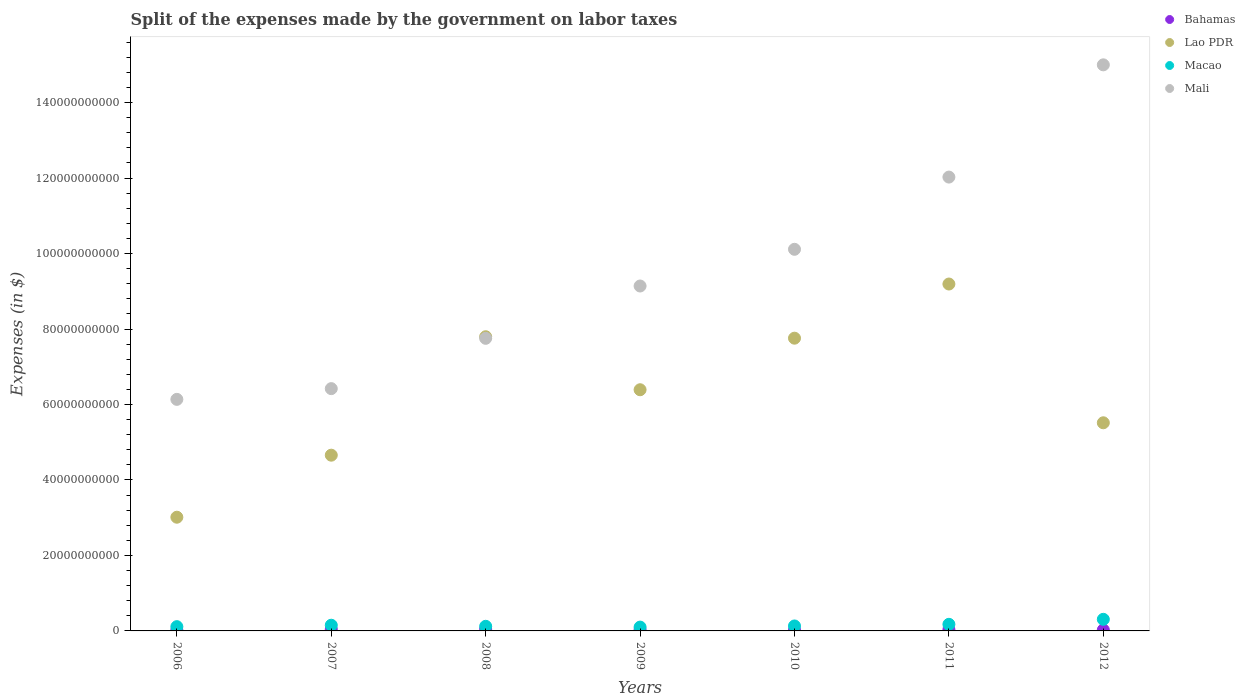How many different coloured dotlines are there?
Make the answer very short. 4. What is the expenses made by the government on labor taxes in Macao in 2008?
Your response must be concise. 1.22e+09. Across all years, what is the maximum expenses made by the government on labor taxes in Lao PDR?
Keep it short and to the point. 9.19e+1. Across all years, what is the minimum expenses made by the government on labor taxes in Lao PDR?
Give a very brief answer. 3.01e+1. What is the total expenses made by the government on labor taxes in Lao PDR in the graph?
Your answer should be very brief. 4.43e+11. What is the difference between the expenses made by the government on labor taxes in Macao in 2006 and that in 2011?
Your answer should be compact. -6.18e+08. What is the difference between the expenses made by the government on labor taxes in Lao PDR in 2006 and the expenses made by the government on labor taxes in Macao in 2007?
Your answer should be very brief. 2.86e+1. What is the average expenses made by the government on labor taxes in Mali per year?
Ensure brevity in your answer.  9.51e+1. In the year 2012, what is the difference between the expenses made by the government on labor taxes in Mali and expenses made by the government on labor taxes in Macao?
Provide a short and direct response. 1.47e+11. What is the ratio of the expenses made by the government on labor taxes in Bahamas in 2008 to that in 2011?
Your response must be concise. 1.42. Is the difference between the expenses made by the government on labor taxes in Mali in 2007 and 2008 greater than the difference between the expenses made by the government on labor taxes in Macao in 2007 and 2008?
Your response must be concise. No. What is the difference between the highest and the second highest expenses made by the government on labor taxes in Mali?
Make the answer very short. 2.97e+1. What is the difference between the highest and the lowest expenses made by the government on labor taxes in Mali?
Provide a succinct answer. 8.86e+1. Is the sum of the expenses made by the government on labor taxes in Mali in 2008 and 2010 greater than the maximum expenses made by the government on labor taxes in Macao across all years?
Offer a terse response. Yes. Is it the case that in every year, the sum of the expenses made by the government on labor taxes in Macao and expenses made by the government on labor taxes in Mali  is greater than the sum of expenses made by the government on labor taxes in Bahamas and expenses made by the government on labor taxes in Lao PDR?
Offer a very short reply. Yes. Is it the case that in every year, the sum of the expenses made by the government on labor taxes in Macao and expenses made by the government on labor taxes in Bahamas  is greater than the expenses made by the government on labor taxes in Mali?
Give a very brief answer. No. Does the expenses made by the government on labor taxes in Bahamas monotonically increase over the years?
Keep it short and to the point. No. Is the expenses made by the government on labor taxes in Macao strictly greater than the expenses made by the government on labor taxes in Mali over the years?
Offer a very short reply. No. Does the graph contain grids?
Make the answer very short. No. How many legend labels are there?
Give a very brief answer. 4. How are the legend labels stacked?
Offer a very short reply. Vertical. What is the title of the graph?
Offer a very short reply. Split of the expenses made by the government on labor taxes. Does "Myanmar" appear as one of the legend labels in the graph?
Ensure brevity in your answer.  No. What is the label or title of the X-axis?
Give a very brief answer. Years. What is the label or title of the Y-axis?
Your answer should be compact. Expenses (in $). What is the Expenses (in $) in Bahamas in 2006?
Offer a very short reply. 2.35e+08. What is the Expenses (in $) of Lao PDR in 2006?
Provide a succinct answer. 3.01e+1. What is the Expenses (in $) in Macao in 2006?
Give a very brief answer. 1.13e+09. What is the Expenses (in $) of Mali in 2006?
Make the answer very short. 6.14e+1. What is the Expenses (in $) in Bahamas in 2007?
Keep it short and to the point. 4.46e+08. What is the Expenses (in $) in Lao PDR in 2007?
Your answer should be very brief. 4.66e+1. What is the Expenses (in $) in Macao in 2007?
Provide a short and direct response. 1.51e+09. What is the Expenses (in $) of Mali in 2007?
Your answer should be compact. 6.42e+1. What is the Expenses (in $) in Bahamas in 2008?
Keep it short and to the point. 4.99e+08. What is the Expenses (in $) of Lao PDR in 2008?
Offer a very short reply. 7.80e+1. What is the Expenses (in $) of Macao in 2008?
Give a very brief answer. 1.22e+09. What is the Expenses (in $) of Mali in 2008?
Ensure brevity in your answer.  7.75e+1. What is the Expenses (in $) in Bahamas in 2009?
Your response must be concise. 2.78e+08. What is the Expenses (in $) of Lao PDR in 2009?
Your answer should be compact. 6.39e+1. What is the Expenses (in $) in Macao in 2009?
Your response must be concise. 1.01e+09. What is the Expenses (in $) in Mali in 2009?
Your answer should be compact. 9.14e+1. What is the Expenses (in $) in Bahamas in 2010?
Your answer should be very brief. 2.53e+08. What is the Expenses (in $) of Lao PDR in 2010?
Offer a very short reply. 7.76e+1. What is the Expenses (in $) in Macao in 2010?
Keep it short and to the point. 1.31e+09. What is the Expenses (in $) of Mali in 2010?
Provide a short and direct response. 1.01e+11. What is the Expenses (in $) in Bahamas in 2011?
Make the answer very short. 3.50e+08. What is the Expenses (in $) of Lao PDR in 2011?
Offer a terse response. 9.19e+1. What is the Expenses (in $) of Macao in 2011?
Offer a terse response. 1.75e+09. What is the Expenses (in $) of Mali in 2011?
Give a very brief answer. 1.20e+11. What is the Expenses (in $) of Bahamas in 2012?
Provide a short and direct response. 2.69e+08. What is the Expenses (in $) in Lao PDR in 2012?
Ensure brevity in your answer.  5.52e+1. What is the Expenses (in $) of Macao in 2012?
Give a very brief answer. 3.07e+09. What is the Expenses (in $) in Mali in 2012?
Offer a terse response. 1.50e+11. Across all years, what is the maximum Expenses (in $) in Bahamas?
Your answer should be very brief. 4.99e+08. Across all years, what is the maximum Expenses (in $) in Lao PDR?
Your response must be concise. 9.19e+1. Across all years, what is the maximum Expenses (in $) of Macao?
Provide a succinct answer. 3.07e+09. Across all years, what is the maximum Expenses (in $) in Mali?
Offer a terse response. 1.50e+11. Across all years, what is the minimum Expenses (in $) in Bahamas?
Offer a terse response. 2.35e+08. Across all years, what is the minimum Expenses (in $) in Lao PDR?
Provide a succinct answer. 3.01e+1. Across all years, what is the minimum Expenses (in $) in Macao?
Ensure brevity in your answer.  1.01e+09. Across all years, what is the minimum Expenses (in $) in Mali?
Offer a terse response. 6.14e+1. What is the total Expenses (in $) of Bahamas in the graph?
Provide a short and direct response. 2.33e+09. What is the total Expenses (in $) in Lao PDR in the graph?
Offer a very short reply. 4.43e+11. What is the total Expenses (in $) of Macao in the graph?
Keep it short and to the point. 1.10e+1. What is the total Expenses (in $) in Mali in the graph?
Ensure brevity in your answer.  6.66e+11. What is the difference between the Expenses (in $) in Bahamas in 2006 and that in 2007?
Your answer should be very brief. -2.10e+08. What is the difference between the Expenses (in $) in Lao PDR in 2006 and that in 2007?
Offer a very short reply. -1.64e+1. What is the difference between the Expenses (in $) of Macao in 2006 and that in 2007?
Provide a succinct answer. -3.76e+08. What is the difference between the Expenses (in $) of Mali in 2006 and that in 2007?
Your answer should be compact. -2.84e+09. What is the difference between the Expenses (in $) in Bahamas in 2006 and that in 2008?
Offer a very short reply. -2.64e+08. What is the difference between the Expenses (in $) of Lao PDR in 2006 and that in 2008?
Offer a terse response. -4.78e+1. What is the difference between the Expenses (in $) in Macao in 2006 and that in 2008?
Your response must be concise. -9.28e+07. What is the difference between the Expenses (in $) in Mali in 2006 and that in 2008?
Your answer should be compact. -1.62e+1. What is the difference between the Expenses (in $) in Bahamas in 2006 and that in 2009?
Provide a short and direct response. -4.27e+07. What is the difference between the Expenses (in $) in Lao PDR in 2006 and that in 2009?
Your answer should be compact. -3.38e+1. What is the difference between the Expenses (in $) of Macao in 2006 and that in 2009?
Give a very brief answer. 1.18e+08. What is the difference between the Expenses (in $) in Mali in 2006 and that in 2009?
Your answer should be compact. -3.00e+1. What is the difference between the Expenses (in $) of Bahamas in 2006 and that in 2010?
Your answer should be compact. -1.79e+07. What is the difference between the Expenses (in $) of Lao PDR in 2006 and that in 2010?
Provide a short and direct response. -4.74e+1. What is the difference between the Expenses (in $) of Macao in 2006 and that in 2010?
Offer a terse response. -1.83e+08. What is the difference between the Expenses (in $) of Mali in 2006 and that in 2010?
Your answer should be very brief. -3.98e+1. What is the difference between the Expenses (in $) of Bahamas in 2006 and that in 2011?
Your answer should be very brief. -1.15e+08. What is the difference between the Expenses (in $) of Lao PDR in 2006 and that in 2011?
Offer a terse response. -6.18e+1. What is the difference between the Expenses (in $) in Macao in 2006 and that in 2011?
Ensure brevity in your answer.  -6.18e+08. What is the difference between the Expenses (in $) of Mali in 2006 and that in 2011?
Provide a succinct answer. -5.89e+1. What is the difference between the Expenses (in $) of Bahamas in 2006 and that in 2012?
Ensure brevity in your answer.  -3.41e+07. What is the difference between the Expenses (in $) of Lao PDR in 2006 and that in 2012?
Keep it short and to the point. -2.50e+1. What is the difference between the Expenses (in $) in Macao in 2006 and that in 2012?
Offer a very short reply. -1.94e+09. What is the difference between the Expenses (in $) in Mali in 2006 and that in 2012?
Keep it short and to the point. -8.86e+1. What is the difference between the Expenses (in $) in Bahamas in 2007 and that in 2008?
Make the answer very short. -5.32e+07. What is the difference between the Expenses (in $) of Lao PDR in 2007 and that in 2008?
Your answer should be very brief. -3.14e+1. What is the difference between the Expenses (in $) in Macao in 2007 and that in 2008?
Keep it short and to the point. 2.83e+08. What is the difference between the Expenses (in $) in Mali in 2007 and that in 2008?
Your answer should be very brief. -1.33e+1. What is the difference between the Expenses (in $) in Bahamas in 2007 and that in 2009?
Ensure brevity in your answer.  1.68e+08. What is the difference between the Expenses (in $) in Lao PDR in 2007 and that in 2009?
Make the answer very short. -1.73e+1. What is the difference between the Expenses (in $) of Macao in 2007 and that in 2009?
Your response must be concise. 4.94e+08. What is the difference between the Expenses (in $) in Mali in 2007 and that in 2009?
Ensure brevity in your answer.  -2.72e+1. What is the difference between the Expenses (in $) in Bahamas in 2007 and that in 2010?
Provide a succinct answer. 1.92e+08. What is the difference between the Expenses (in $) of Lao PDR in 2007 and that in 2010?
Give a very brief answer. -3.10e+1. What is the difference between the Expenses (in $) in Macao in 2007 and that in 2010?
Provide a succinct answer. 1.93e+08. What is the difference between the Expenses (in $) of Mali in 2007 and that in 2010?
Ensure brevity in your answer.  -3.69e+1. What is the difference between the Expenses (in $) in Bahamas in 2007 and that in 2011?
Provide a succinct answer. 9.54e+07. What is the difference between the Expenses (in $) of Lao PDR in 2007 and that in 2011?
Provide a short and direct response. -4.54e+1. What is the difference between the Expenses (in $) in Macao in 2007 and that in 2011?
Your response must be concise. -2.42e+08. What is the difference between the Expenses (in $) in Mali in 2007 and that in 2011?
Provide a short and direct response. -5.61e+1. What is the difference between the Expenses (in $) in Bahamas in 2007 and that in 2012?
Your answer should be very brief. 1.76e+08. What is the difference between the Expenses (in $) in Lao PDR in 2007 and that in 2012?
Offer a very short reply. -8.58e+09. What is the difference between the Expenses (in $) in Macao in 2007 and that in 2012?
Make the answer very short. -1.57e+09. What is the difference between the Expenses (in $) of Mali in 2007 and that in 2012?
Keep it short and to the point. -8.58e+1. What is the difference between the Expenses (in $) of Bahamas in 2008 and that in 2009?
Make the answer very short. 2.21e+08. What is the difference between the Expenses (in $) in Lao PDR in 2008 and that in 2009?
Provide a short and direct response. 1.40e+1. What is the difference between the Expenses (in $) in Macao in 2008 and that in 2009?
Offer a terse response. 2.11e+08. What is the difference between the Expenses (in $) of Mali in 2008 and that in 2009?
Keep it short and to the point. -1.39e+1. What is the difference between the Expenses (in $) in Bahamas in 2008 and that in 2010?
Offer a very short reply. 2.46e+08. What is the difference between the Expenses (in $) of Lao PDR in 2008 and that in 2010?
Make the answer very short. 3.81e+08. What is the difference between the Expenses (in $) in Macao in 2008 and that in 2010?
Your answer should be very brief. -9.05e+07. What is the difference between the Expenses (in $) of Mali in 2008 and that in 2010?
Give a very brief answer. -2.36e+1. What is the difference between the Expenses (in $) of Bahamas in 2008 and that in 2011?
Ensure brevity in your answer.  1.49e+08. What is the difference between the Expenses (in $) in Lao PDR in 2008 and that in 2011?
Offer a terse response. -1.40e+1. What is the difference between the Expenses (in $) of Macao in 2008 and that in 2011?
Make the answer very short. -5.25e+08. What is the difference between the Expenses (in $) in Mali in 2008 and that in 2011?
Ensure brevity in your answer.  -4.27e+1. What is the difference between the Expenses (in $) in Bahamas in 2008 and that in 2012?
Offer a very short reply. 2.29e+08. What is the difference between the Expenses (in $) in Lao PDR in 2008 and that in 2012?
Make the answer very short. 2.28e+1. What is the difference between the Expenses (in $) of Macao in 2008 and that in 2012?
Your answer should be very brief. -1.85e+09. What is the difference between the Expenses (in $) in Mali in 2008 and that in 2012?
Ensure brevity in your answer.  -7.25e+1. What is the difference between the Expenses (in $) in Bahamas in 2009 and that in 2010?
Make the answer very short. 2.47e+07. What is the difference between the Expenses (in $) of Lao PDR in 2009 and that in 2010?
Your answer should be compact. -1.37e+1. What is the difference between the Expenses (in $) in Macao in 2009 and that in 2010?
Offer a terse response. -3.01e+08. What is the difference between the Expenses (in $) of Mali in 2009 and that in 2010?
Your response must be concise. -9.72e+09. What is the difference between the Expenses (in $) of Bahamas in 2009 and that in 2011?
Your answer should be compact. -7.22e+07. What is the difference between the Expenses (in $) of Lao PDR in 2009 and that in 2011?
Your answer should be compact. -2.80e+1. What is the difference between the Expenses (in $) in Macao in 2009 and that in 2011?
Provide a short and direct response. -7.36e+08. What is the difference between the Expenses (in $) of Mali in 2009 and that in 2011?
Ensure brevity in your answer.  -2.89e+1. What is the difference between the Expenses (in $) of Bahamas in 2009 and that in 2012?
Make the answer very short. 8.64e+06. What is the difference between the Expenses (in $) in Lao PDR in 2009 and that in 2012?
Offer a very short reply. 8.76e+09. What is the difference between the Expenses (in $) of Macao in 2009 and that in 2012?
Keep it short and to the point. -2.06e+09. What is the difference between the Expenses (in $) of Mali in 2009 and that in 2012?
Offer a terse response. -5.86e+1. What is the difference between the Expenses (in $) in Bahamas in 2010 and that in 2011?
Ensure brevity in your answer.  -9.70e+07. What is the difference between the Expenses (in $) in Lao PDR in 2010 and that in 2011?
Offer a terse response. -1.43e+1. What is the difference between the Expenses (in $) in Macao in 2010 and that in 2011?
Your answer should be compact. -4.35e+08. What is the difference between the Expenses (in $) of Mali in 2010 and that in 2011?
Ensure brevity in your answer.  -1.91e+1. What is the difference between the Expenses (in $) of Bahamas in 2010 and that in 2012?
Ensure brevity in your answer.  -1.61e+07. What is the difference between the Expenses (in $) of Lao PDR in 2010 and that in 2012?
Ensure brevity in your answer.  2.24e+1. What is the difference between the Expenses (in $) of Macao in 2010 and that in 2012?
Offer a terse response. -1.76e+09. What is the difference between the Expenses (in $) in Mali in 2010 and that in 2012?
Keep it short and to the point. -4.89e+1. What is the difference between the Expenses (in $) of Bahamas in 2011 and that in 2012?
Provide a succinct answer. 8.09e+07. What is the difference between the Expenses (in $) of Lao PDR in 2011 and that in 2012?
Keep it short and to the point. 3.68e+1. What is the difference between the Expenses (in $) in Macao in 2011 and that in 2012?
Your answer should be compact. -1.32e+09. What is the difference between the Expenses (in $) of Mali in 2011 and that in 2012?
Make the answer very short. -2.97e+1. What is the difference between the Expenses (in $) in Bahamas in 2006 and the Expenses (in $) in Lao PDR in 2007?
Your answer should be very brief. -4.63e+1. What is the difference between the Expenses (in $) of Bahamas in 2006 and the Expenses (in $) of Macao in 2007?
Offer a very short reply. -1.27e+09. What is the difference between the Expenses (in $) in Bahamas in 2006 and the Expenses (in $) in Mali in 2007?
Offer a very short reply. -6.40e+1. What is the difference between the Expenses (in $) in Lao PDR in 2006 and the Expenses (in $) in Macao in 2007?
Make the answer very short. 2.86e+1. What is the difference between the Expenses (in $) of Lao PDR in 2006 and the Expenses (in $) of Mali in 2007?
Offer a very short reply. -3.41e+1. What is the difference between the Expenses (in $) of Macao in 2006 and the Expenses (in $) of Mali in 2007?
Your response must be concise. -6.31e+1. What is the difference between the Expenses (in $) in Bahamas in 2006 and the Expenses (in $) in Lao PDR in 2008?
Offer a very short reply. -7.77e+1. What is the difference between the Expenses (in $) in Bahamas in 2006 and the Expenses (in $) in Macao in 2008?
Your answer should be compact. -9.89e+08. What is the difference between the Expenses (in $) in Bahamas in 2006 and the Expenses (in $) in Mali in 2008?
Provide a short and direct response. -7.73e+1. What is the difference between the Expenses (in $) in Lao PDR in 2006 and the Expenses (in $) in Macao in 2008?
Make the answer very short. 2.89e+1. What is the difference between the Expenses (in $) in Lao PDR in 2006 and the Expenses (in $) in Mali in 2008?
Offer a very short reply. -4.74e+1. What is the difference between the Expenses (in $) in Macao in 2006 and the Expenses (in $) in Mali in 2008?
Provide a succinct answer. -7.64e+1. What is the difference between the Expenses (in $) in Bahamas in 2006 and the Expenses (in $) in Lao PDR in 2009?
Keep it short and to the point. -6.37e+1. What is the difference between the Expenses (in $) in Bahamas in 2006 and the Expenses (in $) in Macao in 2009?
Offer a terse response. -7.78e+08. What is the difference between the Expenses (in $) in Bahamas in 2006 and the Expenses (in $) in Mali in 2009?
Make the answer very short. -9.12e+1. What is the difference between the Expenses (in $) in Lao PDR in 2006 and the Expenses (in $) in Macao in 2009?
Ensure brevity in your answer.  2.91e+1. What is the difference between the Expenses (in $) of Lao PDR in 2006 and the Expenses (in $) of Mali in 2009?
Your response must be concise. -6.13e+1. What is the difference between the Expenses (in $) in Macao in 2006 and the Expenses (in $) in Mali in 2009?
Make the answer very short. -9.03e+1. What is the difference between the Expenses (in $) of Bahamas in 2006 and the Expenses (in $) of Lao PDR in 2010?
Your answer should be very brief. -7.73e+1. What is the difference between the Expenses (in $) in Bahamas in 2006 and the Expenses (in $) in Macao in 2010?
Provide a short and direct response. -1.08e+09. What is the difference between the Expenses (in $) in Bahamas in 2006 and the Expenses (in $) in Mali in 2010?
Ensure brevity in your answer.  -1.01e+11. What is the difference between the Expenses (in $) of Lao PDR in 2006 and the Expenses (in $) of Macao in 2010?
Offer a very short reply. 2.88e+1. What is the difference between the Expenses (in $) of Lao PDR in 2006 and the Expenses (in $) of Mali in 2010?
Give a very brief answer. -7.10e+1. What is the difference between the Expenses (in $) of Macao in 2006 and the Expenses (in $) of Mali in 2010?
Keep it short and to the point. -1.00e+11. What is the difference between the Expenses (in $) of Bahamas in 2006 and the Expenses (in $) of Lao PDR in 2011?
Provide a short and direct response. -9.17e+1. What is the difference between the Expenses (in $) in Bahamas in 2006 and the Expenses (in $) in Macao in 2011?
Your answer should be very brief. -1.51e+09. What is the difference between the Expenses (in $) in Bahamas in 2006 and the Expenses (in $) in Mali in 2011?
Make the answer very short. -1.20e+11. What is the difference between the Expenses (in $) of Lao PDR in 2006 and the Expenses (in $) of Macao in 2011?
Your answer should be compact. 2.84e+1. What is the difference between the Expenses (in $) in Lao PDR in 2006 and the Expenses (in $) in Mali in 2011?
Provide a succinct answer. -9.01e+1. What is the difference between the Expenses (in $) in Macao in 2006 and the Expenses (in $) in Mali in 2011?
Ensure brevity in your answer.  -1.19e+11. What is the difference between the Expenses (in $) of Bahamas in 2006 and the Expenses (in $) of Lao PDR in 2012?
Offer a very short reply. -5.49e+1. What is the difference between the Expenses (in $) in Bahamas in 2006 and the Expenses (in $) in Macao in 2012?
Give a very brief answer. -2.84e+09. What is the difference between the Expenses (in $) in Bahamas in 2006 and the Expenses (in $) in Mali in 2012?
Provide a short and direct response. -1.50e+11. What is the difference between the Expenses (in $) of Lao PDR in 2006 and the Expenses (in $) of Macao in 2012?
Offer a very short reply. 2.71e+1. What is the difference between the Expenses (in $) in Lao PDR in 2006 and the Expenses (in $) in Mali in 2012?
Your answer should be very brief. -1.20e+11. What is the difference between the Expenses (in $) in Macao in 2006 and the Expenses (in $) in Mali in 2012?
Provide a succinct answer. -1.49e+11. What is the difference between the Expenses (in $) in Bahamas in 2007 and the Expenses (in $) in Lao PDR in 2008?
Keep it short and to the point. -7.75e+1. What is the difference between the Expenses (in $) of Bahamas in 2007 and the Expenses (in $) of Macao in 2008?
Offer a terse response. -7.78e+08. What is the difference between the Expenses (in $) of Bahamas in 2007 and the Expenses (in $) of Mali in 2008?
Give a very brief answer. -7.71e+1. What is the difference between the Expenses (in $) in Lao PDR in 2007 and the Expenses (in $) in Macao in 2008?
Your answer should be compact. 4.53e+1. What is the difference between the Expenses (in $) in Lao PDR in 2007 and the Expenses (in $) in Mali in 2008?
Give a very brief answer. -3.10e+1. What is the difference between the Expenses (in $) in Macao in 2007 and the Expenses (in $) in Mali in 2008?
Your response must be concise. -7.60e+1. What is the difference between the Expenses (in $) of Bahamas in 2007 and the Expenses (in $) of Lao PDR in 2009?
Your answer should be very brief. -6.35e+1. What is the difference between the Expenses (in $) of Bahamas in 2007 and the Expenses (in $) of Macao in 2009?
Offer a terse response. -5.68e+08. What is the difference between the Expenses (in $) in Bahamas in 2007 and the Expenses (in $) in Mali in 2009?
Your answer should be very brief. -9.09e+1. What is the difference between the Expenses (in $) of Lao PDR in 2007 and the Expenses (in $) of Macao in 2009?
Make the answer very short. 4.56e+1. What is the difference between the Expenses (in $) in Lao PDR in 2007 and the Expenses (in $) in Mali in 2009?
Your response must be concise. -4.48e+1. What is the difference between the Expenses (in $) in Macao in 2007 and the Expenses (in $) in Mali in 2009?
Ensure brevity in your answer.  -8.99e+1. What is the difference between the Expenses (in $) in Bahamas in 2007 and the Expenses (in $) in Lao PDR in 2010?
Give a very brief answer. -7.71e+1. What is the difference between the Expenses (in $) in Bahamas in 2007 and the Expenses (in $) in Macao in 2010?
Your answer should be very brief. -8.69e+08. What is the difference between the Expenses (in $) in Bahamas in 2007 and the Expenses (in $) in Mali in 2010?
Your answer should be very brief. -1.01e+11. What is the difference between the Expenses (in $) in Lao PDR in 2007 and the Expenses (in $) in Macao in 2010?
Ensure brevity in your answer.  4.53e+1. What is the difference between the Expenses (in $) in Lao PDR in 2007 and the Expenses (in $) in Mali in 2010?
Offer a very short reply. -5.46e+1. What is the difference between the Expenses (in $) in Macao in 2007 and the Expenses (in $) in Mali in 2010?
Offer a terse response. -9.96e+1. What is the difference between the Expenses (in $) of Bahamas in 2007 and the Expenses (in $) of Lao PDR in 2011?
Offer a terse response. -9.15e+1. What is the difference between the Expenses (in $) in Bahamas in 2007 and the Expenses (in $) in Macao in 2011?
Make the answer very short. -1.30e+09. What is the difference between the Expenses (in $) of Bahamas in 2007 and the Expenses (in $) of Mali in 2011?
Make the answer very short. -1.20e+11. What is the difference between the Expenses (in $) in Lao PDR in 2007 and the Expenses (in $) in Macao in 2011?
Provide a short and direct response. 4.48e+1. What is the difference between the Expenses (in $) in Lao PDR in 2007 and the Expenses (in $) in Mali in 2011?
Provide a short and direct response. -7.37e+1. What is the difference between the Expenses (in $) of Macao in 2007 and the Expenses (in $) of Mali in 2011?
Offer a very short reply. -1.19e+11. What is the difference between the Expenses (in $) of Bahamas in 2007 and the Expenses (in $) of Lao PDR in 2012?
Give a very brief answer. -5.47e+1. What is the difference between the Expenses (in $) of Bahamas in 2007 and the Expenses (in $) of Macao in 2012?
Ensure brevity in your answer.  -2.63e+09. What is the difference between the Expenses (in $) of Bahamas in 2007 and the Expenses (in $) of Mali in 2012?
Offer a terse response. -1.50e+11. What is the difference between the Expenses (in $) of Lao PDR in 2007 and the Expenses (in $) of Macao in 2012?
Provide a short and direct response. 4.35e+1. What is the difference between the Expenses (in $) of Lao PDR in 2007 and the Expenses (in $) of Mali in 2012?
Keep it short and to the point. -1.03e+11. What is the difference between the Expenses (in $) in Macao in 2007 and the Expenses (in $) in Mali in 2012?
Make the answer very short. -1.48e+11. What is the difference between the Expenses (in $) of Bahamas in 2008 and the Expenses (in $) of Lao PDR in 2009?
Provide a short and direct response. -6.34e+1. What is the difference between the Expenses (in $) of Bahamas in 2008 and the Expenses (in $) of Macao in 2009?
Ensure brevity in your answer.  -5.14e+08. What is the difference between the Expenses (in $) in Bahamas in 2008 and the Expenses (in $) in Mali in 2009?
Your response must be concise. -9.09e+1. What is the difference between the Expenses (in $) in Lao PDR in 2008 and the Expenses (in $) in Macao in 2009?
Your answer should be compact. 7.69e+1. What is the difference between the Expenses (in $) in Lao PDR in 2008 and the Expenses (in $) in Mali in 2009?
Make the answer very short. -1.34e+1. What is the difference between the Expenses (in $) of Macao in 2008 and the Expenses (in $) of Mali in 2009?
Provide a short and direct response. -9.02e+1. What is the difference between the Expenses (in $) in Bahamas in 2008 and the Expenses (in $) in Lao PDR in 2010?
Offer a very short reply. -7.71e+1. What is the difference between the Expenses (in $) in Bahamas in 2008 and the Expenses (in $) in Macao in 2010?
Keep it short and to the point. -8.16e+08. What is the difference between the Expenses (in $) of Bahamas in 2008 and the Expenses (in $) of Mali in 2010?
Your response must be concise. -1.01e+11. What is the difference between the Expenses (in $) of Lao PDR in 2008 and the Expenses (in $) of Macao in 2010?
Your response must be concise. 7.66e+1. What is the difference between the Expenses (in $) of Lao PDR in 2008 and the Expenses (in $) of Mali in 2010?
Your response must be concise. -2.32e+1. What is the difference between the Expenses (in $) in Macao in 2008 and the Expenses (in $) in Mali in 2010?
Your answer should be very brief. -9.99e+1. What is the difference between the Expenses (in $) of Bahamas in 2008 and the Expenses (in $) of Lao PDR in 2011?
Keep it short and to the point. -9.14e+1. What is the difference between the Expenses (in $) in Bahamas in 2008 and the Expenses (in $) in Macao in 2011?
Provide a short and direct response. -1.25e+09. What is the difference between the Expenses (in $) of Bahamas in 2008 and the Expenses (in $) of Mali in 2011?
Your answer should be very brief. -1.20e+11. What is the difference between the Expenses (in $) in Lao PDR in 2008 and the Expenses (in $) in Macao in 2011?
Provide a succinct answer. 7.62e+1. What is the difference between the Expenses (in $) of Lao PDR in 2008 and the Expenses (in $) of Mali in 2011?
Make the answer very short. -4.23e+1. What is the difference between the Expenses (in $) in Macao in 2008 and the Expenses (in $) in Mali in 2011?
Keep it short and to the point. -1.19e+11. What is the difference between the Expenses (in $) in Bahamas in 2008 and the Expenses (in $) in Lao PDR in 2012?
Provide a succinct answer. -5.47e+1. What is the difference between the Expenses (in $) of Bahamas in 2008 and the Expenses (in $) of Macao in 2012?
Give a very brief answer. -2.57e+09. What is the difference between the Expenses (in $) in Bahamas in 2008 and the Expenses (in $) in Mali in 2012?
Your answer should be very brief. -1.50e+11. What is the difference between the Expenses (in $) in Lao PDR in 2008 and the Expenses (in $) in Macao in 2012?
Give a very brief answer. 7.49e+1. What is the difference between the Expenses (in $) of Lao PDR in 2008 and the Expenses (in $) of Mali in 2012?
Offer a terse response. -7.20e+1. What is the difference between the Expenses (in $) of Macao in 2008 and the Expenses (in $) of Mali in 2012?
Keep it short and to the point. -1.49e+11. What is the difference between the Expenses (in $) of Bahamas in 2009 and the Expenses (in $) of Lao PDR in 2010?
Offer a very short reply. -7.73e+1. What is the difference between the Expenses (in $) of Bahamas in 2009 and the Expenses (in $) of Macao in 2010?
Give a very brief answer. -1.04e+09. What is the difference between the Expenses (in $) in Bahamas in 2009 and the Expenses (in $) in Mali in 2010?
Keep it short and to the point. -1.01e+11. What is the difference between the Expenses (in $) of Lao PDR in 2009 and the Expenses (in $) of Macao in 2010?
Your response must be concise. 6.26e+1. What is the difference between the Expenses (in $) of Lao PDR in 2009 and the Expenses (in $) of Mali in 2010?
Ensure brevity in your answer.  -3.72e+1. What is the difference between the Expenses (in $) in Macao in 2009 and the Expenses (in $) in Mali in 2010?
Offer a terse response. -1.00e+11. What is the difference between the Expenses (in $) of Bahamas in 2009 and the Expenses (in $) of Lao PDR in 2011?
Your answer should be compact. -9.16e+1. What is the difference between the Expenses (in $) of Bahamas in 2009 and the Expenses (in $) of Macao in 2011?
Offer a very short reply. -1.47e+09. What is the difference between the Expenses (in $) of Bahamas in 2009 and the Expenses (in $) of Mali in 2011?
Keep it short and to the point. -1.20e+11. What is the difference between the Expenses (in $) of Lao PDR in 2009 and the Expenses (in $) of Macao in 2011?
Your answer should be very brief. 6.22e+1. What is the difference between the Expenses (in $) in Lao PDR in 2009 and the Expenses (in $) in Mali in 2011?
Your response must be concise. -5.63e+1. What is the difference between the Expenses (in $) in Macao in 2009 and the Expenses (in $) in Mali in 2011?
Keep it short and to the point. -1.19e+11. What is the difference between the Expenses (in $) of Bahamas in 2009 and the Expenses (in $) of Lao PDR in 2012?
Offer a terse response. -5.49e+1. What is the difference between the Expenses (in $) of Bahamas in 2009 and the Expenses (in $) of Macao in 2012?
Give a very brief answer. -2.79e+09. What is the difference between the Expenses (in $) in Bahamas in 2009 and the Expenses (in $) in Mali in 2012?
Make the answer very short. -1.50e+11. What is the difference between the Expenses (in $) of Lao PDR in 2009 and the Expenses (in $) of Macao in 2012?
Provide a short and direct response. 6.08e+1. What is the difference between the Expenses (in $) in Lao PDR in 2009 and the Expenses (in $) in Mali in 2012?
Make the answer very short. -8.61e+1. What is the difference between the Expenses (in $) in Macao in 2009 and the Expenses (in $) in Mali in 2012?
Your answer should be very brief. -1.49e+11. What is the difference between the Expenses (in $) of Bahamas in 2010 and the Expenses (in $) of Lao PDR in 2011?
Ensure brevity in your answer.  -9.17e+1. What is the difference between the Expenses (in $) of Bahamas in 2010 and the Expenses (in $) of Macao in 2011?
Your answer should be very brief. -1.50e+09. What is the difference between the Expenses (in $) of Bahamas in 2010 and the Expenses (in $) of Mali in 2011?
Your response must be concise. -1.20e+11. What is the difference between the Expenses (in $) in Lao PDR in 2010 and the Expenses (in $) in Macao in 2011?
Make the answer very short. 7.58e+1. What is the difference between the Expenses (in $) of Lao PDR in 2010 and the Expenses (in $) of Mali in 2011?
Your response must be concise. -4.27e+1. What is the difference between the Expenses (in $) of Macao in 2010 and the Expenses (in $) of Mali in 2011?
Give a very brief answer. -1.19e+11. What is the difference between the Expenses (in $) in Bahamas in 2010 and the Expenses (in $) in Lao PDR in 2012?
Make the answer very short. -5.49e+1. What is the difference between the Expenses (in $) in Bahamas in 2010 and the Expenses (in $) in Macao in 2012?
Offer a terse response. -2.82e+09. What is the difference between the Expenses (in $) of Bahamas in 2010 and the Expenses (in $) of Mali in 2012?
Provide a succinct answer. -1.50e+11. What is the difference between the Expenses (in $) of Lao PDR in 2010 and the Expenses (in $) of Macao in 2012?
Make the answer very short. 7.45e+1. What is the difference between the Expenses (in $) of Lao PDR in 2010 and the Expenses (in $) of Mali in 2012?
Your response must be concise. -7.24e+1. What is the difference between the Expenses (in $) in Macao in 2010 and the Expenses (in $) in Mali in 2012?
Your response must be concise. -1.49e+11. What is the difference between the Expenses (in $) of Bahamas in 2011 and the Expenses (in $) of Lao PDR in 2012?
Your response must be concise. -5.48e+1. What is the difference between the Expenses (in $) in Bahamas in 2011 and the Expenses (in $) in Macao in 2012?
Offer a terse response. -2.72e+09. What is the difference between the Expenses (in $) of Bahamas in 2011 and the Expenses (in $) of Mali in 2012?
Provide a short and direct response. -1.50e+11. What is the difference between the Expenses (in $) in Lao PDR in 2011 and the Expenses (in $) in Macao in 2012?
Provide a succinct answer. 8.88e+1. What is the difference between the Expenses (in $) of Lao PDR in 2011 and the Expenses (in $) of Mali in 2012?
Keep it short and to the point. -5.81e+1. What is the difference between the Expenses (in $) in Macao in 2011 and the Expenses (in $) in Mali in 2012?
Provide a succinct answer. -1.48e+11. What is the average Expenses (in $) of Bahamas per year?
Offer a very short reply. 3.33e+08. What is the average Expenses (in $) in Lao PDR per year?
Your response must be concise. 6.33e+1. What is the average Expenses (in $) of Macao per year?
Provide a short and direct response. 1.57e+09. What is the average Expenses (in $) in Mali per year?
Give a very brief answer. 9.51e+1. In the year 2006, what is the difference between the Expenses (in $) of Bahamas and Expenses (in $) of Lao PDR?
Give a very brief answer. -2.99e+1. In the year 2006, what is the difference between the Expenses (in $) of Bahamas and Expenses (in $) of Macao?
Provide a short and direct response. -8.96e+08. In the year 2006, what is the difference between the Expenses (in $) of Bahamas and Expenses (in $) of Mali?
Your answer should be compact. -6.11e+1. In the year 2006, what is the difference between the Expenses (in $) of Lao PDR and Expenses (in $) of Macao?
Your answer should be very brief. 2.90e+1. In the year 2006, what is the difference between the Expenses (in $) of Lao PDR and Expenses (in $) of Mali?
Give a very brief answer. -3.12e+1. In the year 2006, what is the difference between the Expenses (in $) in Macao and Expenses (in $) in Mali?
Keep it short and to the point. -6.02e+1. In the year 2007, what is the difference between the Expenses (in $) in Bahamas and Expenses (in $) in Lao PDR?
Offer a terse response. -4.61e+1. In the year 2007, what is the difference between the Expenses (in $) of Bahamas and Expenses (in $) of Macao?
Ensure brevity in your answer.  -1.06e+09. In the year 2007, what is the difference between the Expenses (in $) in Bahamas and Expenses (in $) in Mali?
Offer a very short reply. -6.38e+1. In the year 2007, what is the difference between the Expenses (in $) of Lao PDR and Expenses (in $) of Macao?
Offer a terse response. 4.51e+1. In the year 2007, what is the difference between the Expenses (in $) in Lao PDR and Expenses (in $) in Mali?
Make the answer very short. -1.76e+1. In the year 2007, what is the difference between the Expenses (in $) of Macao and Expenses (in $) of Mali?
Your answer should be compact. -6.27e+1. In the year 2008, what is the difference between the Expenses (in $) in Bahamas and Expenses (in $) in Lao PDR?
Provide a short and direct response. -7.75e+1. In the year 2008, what is the difference between the Expenses (in $) in Bahamas and Expenses (in $) in Macao?
Make the answer very short. -7.25e+08. In the year 2008, what is the difference between the Expenses (in $) in Bahamas and Expenses (in $) in Mali?
Provide a succinct answer. -7.70e+1. In the year 2008, what is the difference between the Expenses (in $) in Lao PDR and Expenses (in $) in Macao?
Give a very brief answer. 7.67e+1. In the year 2008, what is the difference between the Expenses (in $) of Lao PDR and Expenses (in $) of Mali?
Ensure brevity in your answer.  4.21e+08. In the year 2008, what is the difference between the Expenses (in $) in Macao and Expenses (in $) in Mali?
Give a very brief answer. -7.63e+1. In the year 2009, what is the difference between the Expenses (in $) of Bahamas and Expenses (in $) of Lao PDR?
Give a very brief answer. -6.36e+1. In the year 2009, what is the difference between the Expenses (in $) of Bahamas and Expenses (in $) of Macao?
Offer a terse response. -7.35e+08. In the year 2009, what is the difference between the Expenses (in $) of Bahamas and Expenses (in $) of Mali?
Your response must be concise. -9.11e+1. In the year 2009, what is the difference between the Expenses (in $) of Lao PDR and Expenses (in $) of Macao?
Give a very brief answer. 6.29e+1. In the year 2009, what is the difference between the Expenses (in $) of Lao PDR and Expenses (in $) of Mali?
Provide a succinct answer. -2.75e+1. In the year 2009, what is the difference between the Expenses (in $) in Macao and Expenses (in $) in Mali?
Offer a terse response. -9.04e+1. In the year 2010, what is the difference between the Expenses (in $) of Bahamas and Expenses (in $) of Lao PDR?
Your answer should be very brief. -7.73e+1. In the year 2010, what is the difference between the Expenses (in $) in Bahamas and Expenses (in $) in Macao?
Provide a short and direct response. -1.06e+09. In the year 2010, what is the difference between the Expenses (in $) in Bahamas and Expenses (in $) in Mali?
Make the answer very short. -1.01e+11. In the year 2010, what is the difference between the Expenses (in $) in Lao PDR and Expenses (in $) in Macao?
Your answer should be compact. 7.63e+1. In the year 2010, what is the difference between the Expenses (in $) in Lao PDR and Expenses (in $) in Mali?
Offer a terse response. -2.36e+1. In the year 2010, what is the difference between the Expenses (in $) of Macao and Expenses (in $) of Mali?
Your answer should be compact. -9.98e+1. In the year 2011, what is the difference between the Expenses (in $) in Bahamas and Expenses (in $) in Lao PDR?
Give a very brief answer. -9.16e+1. In the year 2011, what is the difference between the Expenses (in $) in Bahamas and Expenses (in $) in Macao?
Your response must be concise. -1.40e+09. In the year 2011, what is the difference between the Expenses (in $) of Bahamas and Expenses (in $) of Mali?
Give a very brief answer. -1.20e+11. In the year 2011, what is the difference between the Expenses (in $) of Lao PDR and Expenses (in $) of Macao?
Ensure brevity in your answer.  9.02e+1. In the year 2011, what is the difference between the Expenses (in $) in Lao PDR and Expenses (in $) in Mali?
Make the answer very short. -2.83e+1. In the year 2011, what is the difference between the Expenses (in $) in Macao and Expenses (in $) in Mali?
Offer a very short reply. -1.19e+11. In the year 2012, what is the difference between the Expenses (in $) in Bahamas and Expenses (in $) in Lao PDR?
Give a very brief answer. -5.49e+1. In the year 2012, what is the difference between the Expenses (in $) in Bahamas and Expenses (in $) in Macao?
Offer a very short reply. -2.80e+09. In the year 2012, what is the difference between the Expenses (in $) of Bahamas and Expenses (in $) of Mali?
Offer a very short reply. -1.50e+11. In the year 2012, what is the difference between the Expenses (in $) of Lao PDR and Expenses (in $) of Macao?
Your answer should be compact. 5.21e+1. In the year 2012, what is the difference between the Expenses (in $) of Lao PDR and Expenses (in $) of Mali?
Provide a succinct answer. -9.48e+1. In the year 2012, what is the difference between the Expenses (in $) in Macao and Expenses (in $) in Mali?
Provide a short and direct response. -1.47e+11. What is the ratio of the Expenses (in $) of Bahamas in 2006 to that in 2007?
Ensure brevity in your answer.  0.53. What is the ratio of the Expenses (in $) in Lao PDR in 2006 to that in 2007?
Your answer should be compact. 0.65. What is the ratio of the Expenses (in $) of Macao in 2006 to that in 2007?
Ensure brevity in your answer.  0.75. What is the ratio of the Expenses (in $) of Mali in 2006 to that in 2007?
Keep it short and to the point. 0.96. What is the ratio of the Expenses (in $) in Bahamas in 2006 to that in 2008?
Make the answer very short. 0.47. What is the ratio of the Expenses (in $) of Lao PDR in 2006 to that in 2008?
Offer a very short reply. 0.39. What is the ratio of the Expenses (in $) of Macao in 2006 to that in 2008?
Provide a short and direct response. 0.92. What is the ratio of the Expenses (in $) of Mali in 2006 to that in 2008?
Your response must be concise. 0.79. What is the ratio of the Expenses (in $) in Bahamas in 2006 to that in 2009?
Provide a succinct answer. 0.85. What is the ratio of the Expenses (in $) in Lao PDR in 2006 to that in 2009?
Provide a short and direct response. 0.47. What is the ratio of the Expenses (in $) in Macao in 2006 to that in 2009?
Offer a terse response. 1.12. What is the ratio of the Expenses (in $) in Mali in 2006 to that in 2009?
Provide a short and direct response. 0.67. What is the ratio of the Expenses (in $) of Bahamas in 2006 to that in 2010?
Offer a terse response. 0.93. What is the ratio of the Expenses (in $) of Lao PDR in 2006 to that in 2010?
Ensure brevity in your answer.  0.39. What is the ratio of the Expenses (in $) in Macao in 2006 to that in 2010?
Provide a short and direct response. 0.86. What is the ratio of the Expenses (in $) in Mali in 2006 to that in 2010?
Offer a very short reply. 0.61. What is the ratio of the Expenses (in $) of Bahamas in 2006 to that in 2011?
Give a very brief answer. 0.67. What is the ratio of the Expenses (in $) in Lao PDR in 2006 to that in 2011?
Offer a very short reply. 0.33. What is the ratio of the Expenses (in $) in Macao in 2006 to that in 2011?
Keep it short and to the point. 0.65. What is the ratio of the Expenses (in $) of Mali in 2006 to that in 2011?
Your response must be concise. 0.51. What is the ratio of the Expenses (in $) of Bahamas in 2006 to that in 2012?
Offer a very short reply. 0.87. What is the ratio of the Expenses (in $) in Lao PDR in 2006 to that in 2012?
Your response must be concise. 0.55. What is the ratio of the Expenses (in $) of Macao in 2006 to that in 2012?
Keep it short and to the point. 0.37. What is the ratio of the Expenses (in $) in Mali in 2006 to that in 2012?
Your answer should be compact. 0.41. What is the ratio of the Expenses (in $) of Bahamas in 2007 to that in 2008?
Provide a short and direct response. 0.89. What is the ratio of the Expenses (in $) in Lao PDR in 2007 to that in 2008?
Your response must be concise. 0.6. What is the ratio of the Expenses (in $) of Macao in 2007 to that in 2008?
Ensure brevity in your answer.  1.23. What is the ratio of the Expenses (in $) of Mali in 2007 to that in 2008?
Provide a succinct answer. 0.83. What is the ratio of the Expenses (in $) of Bahamas in 2007 to that in 2009?
Ensure brevity in your answer.  1.6. What is the ratio of the Expenses (in $) of Lao PDR in 2007 to that in 2009?
Your response must be concise. 0.73. What is the ratio of the Expenses (in $) in Macao in 2007 to that in 2009?
Make the answer very short. 1.49. What is the ratio of the Expenses (in $) of Mali in 2007 to that in 2009?
Provide a succinct answer. 0.7. What is the ratio of the Expenses (in $) of Bahamas in 2007 to that in 2010?
Your answer should be compact. 1.76. What is the ratio of the Expenses (in $) of Lao PDR in 2007 to that in 2010?
Offer a very short reply. 0.6. What is the ratio of the Expenses (in $) in Macao in 2007 to that in 2010?
Make the answer very short. 1.15. What is the ratio of the Expenses (in $) in Mali in 2007 to that in 2010?
Keep it short and to the point. 0.63. What is the ratio of the Expenses (in $) of Bahamas in 2007 to that in 2011?
Your answer should be very brief. 1.27. What is the ratio of the Expenses (in $) in Lao PDR in 2007 to that in 2011?
Give a very brief answer. 0.51. What is the ratio of the Expenses (in $) in Macao in 2007 to that in 2011?
Give a very brief answer. 0.86. What is the ratio of the Expenses (in $) of Mali in 2007 to that in 2011?
Offer a terse response. 0.53. What is the ratio of the Expenses (in $) in Bahamas in 2007 to that in 2012?
Your response must be concise. 1.65. What is the ratio of the Expenses (in $) in Lao PDR in 2007 to that in 2012?
Provide a short and direct response. 0.84. What is the ratio of the Expenses (in $) in Macao in 2007 to that in 2012?
Keep it short and to the point. 0.49. What is the ratio of the Expenses (in $) of Mali in 2007 to that in 2012?
Keep it short and to the point. 0.43. What is the ratio of the Expenses (in $) of Bahamas in 2008 to that in 2009?
Make the answer very short. 1.79. What is the ratio of the Expenses (in $) in Lao PDR in 2008 to that in 2009?
Provide a succinct answer. 1.22. What is the ratio of the Expenses (in $) of Macao in 2008 to that in 2009?
Give a very brief answer. 1.21. What is the ratio of the Expenses (in $) in Mali in 2008 to that in 2009?
Make the answer very short. 0.85. What is the ratio of the Expenses (in $) of Bahamas in 2008 to that in 2010?
Provide a short and direct response. 1.97. What is the ratio of the Expenses (in $) in Lao PDR in 2008 to that in 2010?
Your answer should be very brief. 1. What is the ratio of the Expenses (in $) of Macao in 2008 to that in 2010?
Offer a very short reply. 0.93. What is the ratio of the Expenses (in $) of Mali in 2008 to that in 2010?
Ensure brevity in your answer.  0.77. What is the ratio of the Expenses (in $) of Bahamas in 2008 to that in 2011?
Make the answer very short. 1.42. What is the ratio of the Expenses (in $) of Lao PDR in 2008 to that in 2011?
Your answer should be very brief. 0.85. What is the ratio of the Expenses (in $) in Macao in 2008 to that in 2011?
Make the answer very short. 0.7. What is the ratio of the Expenses (in $) of Mali in 2008 to that in 2011?
Provide a succinct answer. 0.64. What is the ratio of the Expenses (in $) in Bahamas in 2008 to that in 2012?
Ensure brevity in your answer.  1.85. What is the ratio of the Expenses (in $) in Lao PDR in 2008 to that in 2012?
Offer a very short reply. 1.41. What is the ratio of the Expenses (in $) in Macao in 2008 to that in 2012?
Give a very brief answer. 0.4. What is the ratio of the Expenses (in $) in Mali in 2008 to that in 2012?
Give a very brief answer. 0.52. What is the ratio of the Expenses (in $) in Bahamas in 2009 to that in 2010?
Your answer should be very brief. 1.1. What is the ratio of the Expenses (in $) of Lao PDR in 2009 to that in 2010?
Provide a short and direct response. 0.82. What is the ratio of the Expenses (in $) of Macao in 2009 to that in 2010?
Offer a terse response. 0.77. What is the ratio of the Expenses (in $) of Mali in 2009 to that in 2010?
Ensure brevity in your answer.  0.9. What is the ratio of the Expenses (in $) of Bahamas in 2009 to that in 2011?
Your response must be concise. 0.79. What is the ratio of the Expenses (in $) in Lao PDR in 2009 to that in 2011?
Give a very brief answer. 0.7. What is the ratio of the Expenses (in $) of Macao in 2009 to that in 2011?
Make the answer very short. 0.58. What is the ratio of the Expenses (in $) of Mali in 2009 to that in 2011?
Provide a short and direct response. 0.76. What is the ratio of the Expenses (in $) in Bahamas in 2009 to that in 2012?
Provide a short and direct response. 1.03. What is the ratio of the Expenses (in $) of Lao PDR in 2009 to that in 2012?
Your answer should be compact. 1.16. What is the ratio of the Expenses (in $) in Macao in 2009 to that in 2012?
Your answer should be very brief. 0.33. What is the ratio of the Expenses (in $) of Mali in 2009 to that in 2012?
Give a very brief answer. 0.61. What is the ratio of the Expenses (in $) of Bahamas in 2010 to that in 2011?
Keep it short and to the point. 0.72. What is the ratio of the Expenses (in $) in Lao PDR in 2010 to that in 2011?
Provide a short and direct response. 0.84. What is the ratio of the Expenses (in $) in Macao in 2010 to that in 2011?
Keep it short and to the point. 0.75. What is the ratio of the Expenses (in $) in Mali in 2010 to that in 2011?
Offer a terse response. 0.84. What is the ratio of the Expenses (in $) of Bahamas in 2010 to that in 2012?
Give a very brief answer. 0.94. What is the ratio of the Expenses (in $) in Lao PDR in 2010 to that in 2012?
Keep it short and to the point. 1.41. What is the ratio of the Expenses (in $) of Macao in 2010 to that in 2012?
Offer a terse response. 0.43. What is the ratio of the Expenses (in $) in Mali in 2010 to that in 2012?
Offer a terse response. 0.67. What is the ratio of the Expenses (in $) of Bahamas in 2011 to that in 2012?
Your answer should be very brief. 1.3. What is the ratio of the Expenses (in $) of Lao PDR in 2011 to that in 2012?
Your answer should be compact. 1.67. What is the ratio of the Expenses (in $) of Macao in 2011 to that in 2012?
Offer a terse response. 0.57. What is the ratio of the Expenses (in $) in Mali in 2011 to that in 2012?
Offer a very short reply. 0.8. What is the difference between the highest and the second highest Expenses (in $) of Bahamas?
Your response must be concise. 5.32e+07. What is the difference between the highest and the second highest Expenses (in $) in Lao PDR?
Your answer should be very brief. 1.40e+1. What is the difference between the highest and the second highest Expenses (in $) in Macao?
Ensure brevity in your answer.  1.32e+09. What is the difference between the highest and the second highest Expenses (in $) of Mali?
Keep it short and to the point. 2.97e+1. What is the difference between the highest and the lowest Expenses (in $) of Bahamas?
Your response must be concise. 2.64e+08. What is the difference between the highest and the lowest Expenses (in $) in Lao PDR?
Your answer should be very brief. 6.18e+1. What is the difference between the highest and the lowest Expenses (in $) of Macao?
Offer a very short reply. 2.06e+09. What is the difference between the highest and the lowest Expenses (in $) of Mali?
Make the answer very short. 8.86e+1. 